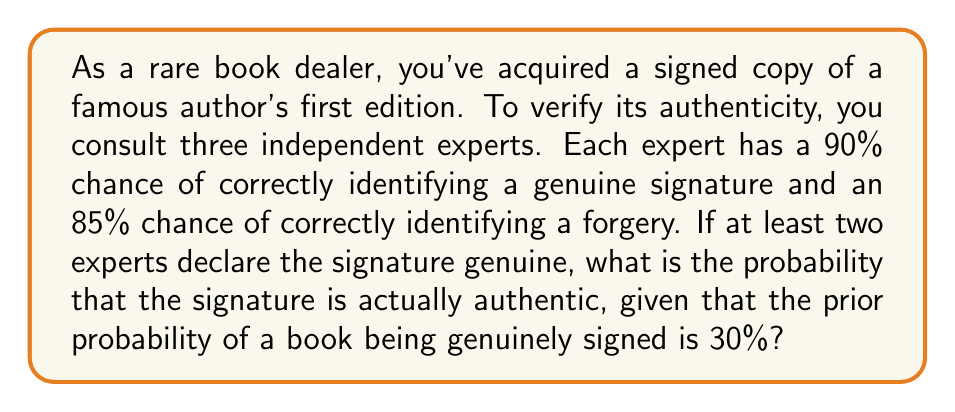Give your solution to this math problem. Let's approach this problem using Bayes' theorem and probability theory:

1) Define events:
   A: The signature is authentic
   B: At least two experts declare the signature genuine

2) We need to find P(A|B) using Bayes' theorem:

   $$P(A|B) = \frac{P(B|A) \cdot P(A)}{P(B)}$$

3) Given information:
   P(A) = 0.30 (prior probability of authenticity)
   P(expert correctly identifies genuine) = 0.90
   P(expert correctly identifies forgery) = 0.85

4) Calculate P(B|A):
   This is the probability that at least 2 out of 3 experts declare it genuine when it is authentic.
   $$P(B|A) = \binom{3}{3}(0.9)^3 + \binom{3}{2}(0.9)^2(0.1) = 0.972$$

5) Calculate P(B|not A):
   This is the probability that at least 2 out of 3 experts incorrectly declare it genuine when it's not authentic.
   $$P(B|not A) = \binom{3}{3}(0.15)^3 + \binom{3}{2}(0.15)^2(0.85) = 0.0115$$

6) Calculate P(B):
   $$P(B) = P(B|A) \cdot P(A) + P(B|not A) \cdot P(not A)$$
   $$P(B) = 0.972 \cdot 0.30 + 0.0115 \cdot 0.70 = 0.2996$$

7) Apply Bayes' theorem:
   $$P(A|B) = \frac{0.972 \cdot 0.30}{0.2996} \approx 0.9734$$

Therefore, the probability that the signature is authentic, given that at least two experts declared it genuine, is approximately 0.9734 or 97.34%.
Answer: 0.9734 or 97.34% 